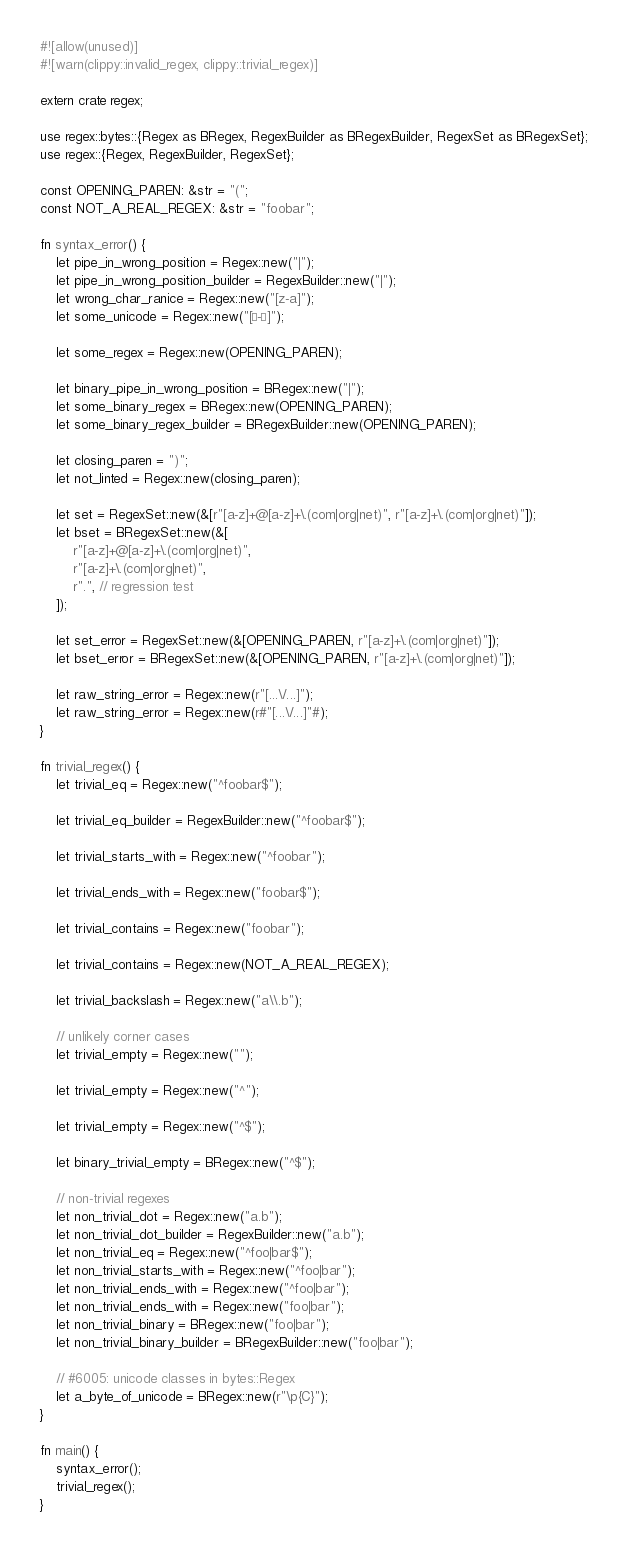<code> <loc_0><loc_0><loc_500><loc_500><_Rust_>#![allow(unused)]
#![warn(clippy::invalid_regex, clippy::trivial_regex)]

extern crate regex;

use regex::bytes::{Regex as BRegex, RegexBuilder as BRegexBuilder, RegexSet as BRegexSet};
use regex::{Regex, RegexBuilder, RegexSet};

const OPENING_PAREN: &str = "(";
const NOT_A_REAL_REGEX: &str = "foobar";

fn syntax_error() {
    let pipe_in_wrong_position = Regex::new("|");
    let pipe_in_wrong_position_builder = RegexBuilder::new("|");
    let wrong_char_ranice = Regex::new("[z-a]");
    let some_unicode = Regex::new("[é-è]");

    let some_regex = Regex::new(OPENING_PAREN);

    let binary_pipe_in_wrong_position = BRegex::new("|");
    let some_binary_regex = BRegex::new(OPENING_PAREN);
    let some_binary_regex_builder = BRegexBuilder::new(OPENING_PAREN);

    let closing_paren = ")";
    let not_linted = Regex::new(closing_paren);

    let set = RegexSet::new(&[r"[a-z]+@[a-z]+\.(com|org|net)", r"[a-z]+\.(com|org|net)"]);
    let bset = BRegexSet::new(&[
        r"[a-z]+@[a-z]+\.(com|org|net)",
        r"[a-z]+\.(com|org|net)",
        r".", // regression test
    ]);

    let set_error = RegexSet::new(&[OPENING_PAREN, r"[a-z]+\.(com|org|net)"]);
    let bset_error = BRegexSet::new(&[OPENING_PAREN, r"[a-z]+\.(com|org|net)"]);

    let raw_string_error = Regex::new(r"[...\/...]");
    let raw_string_error = Regex::new(r#"[...\/...]"#);
}

fn trivial_regex() {
    let trivial_eq = Regex::new("^foobar$");

    let trivial_eq_builder = RegexBuilder::new("^foobar$");

    let trivial_starts_with = Regex::new("^foobar");

    let trivial_ends_with = Regex::new("foobar$");

    let trivial_contains = Regex::new("foobar");

    let trivial_contains = Regex::new(NOT_A_REAL_REGEX);

    let trivial_backslash = Regex::new("a\\.b");

    // unlikely corner cases
    let trivial_empty = Regex::new("");

    let trivial_empty = Regex::new("^");

    let trivial_empty = Regex::new("^$");

    let binary_trivial_empty = BRegex::new("^$");

    // non-trivial regexes
    let non_trivial_dot = Regex::new("a.b");
    let non_trivial_dot_builder = RegexBuilder::new("a.b");
    let non_trivial_eq = Regex::new("^foo|bar$");
    let non_trivial_starts_with = Regex::new("^foo|bar");
    let non_trivial_ends_with = Regex::new("^foo|bar");
    let non_trivial_ends_with = Regex::new("foo|bar");
    let non_trivial_binary = BRegex::new("foo|bar");
    let non_trivial_binary_builder = BRegexBuilder::new("foo|bar");

    // #6005: unicode classes in bytes::Regex
    let a_byte_of_unicode = BRegex::new(r"\p{C}");
}

fn main() {
    syntax_error();
    trivial_regex();
}
</code> 